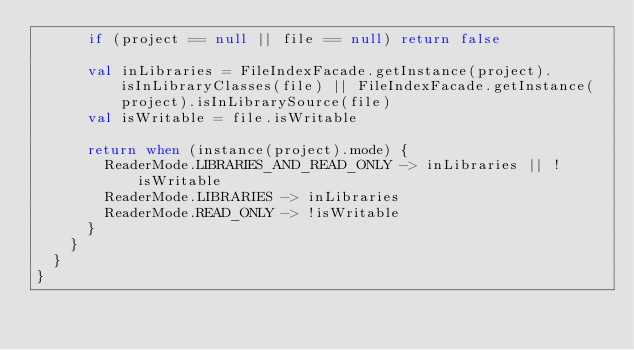<code> <loc_0><loc_0><loc_500><loc_500><_Kotlin_>      if (project == null || file == null) return false

      val inLibraries = FileIndexFacade.getInstance(project).isInLibraryClasses(file) || FileIndexFacade.getInstance(project).isInLibrarySource(file)
      val isWritable = file.isWritable

      return when (instance(project).mode) {
        ReaderMode.LIBRARIES_AND_READ_ONLY -> inLibraries || !isWritable
        ReaderMode.LIBRARIES -> inLibraries
        ReaderMode.READ_ONLY -> !isWritable
      }
    }
  }
}</code> 